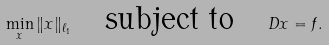Convert formula to latex. <formula><loc_0><loc_0><loc_500><loc_500>\min _ { x } \| x \| _ { \ell _ { 1 } } \quad \text {subject to} \quad D x = f .</formula> 